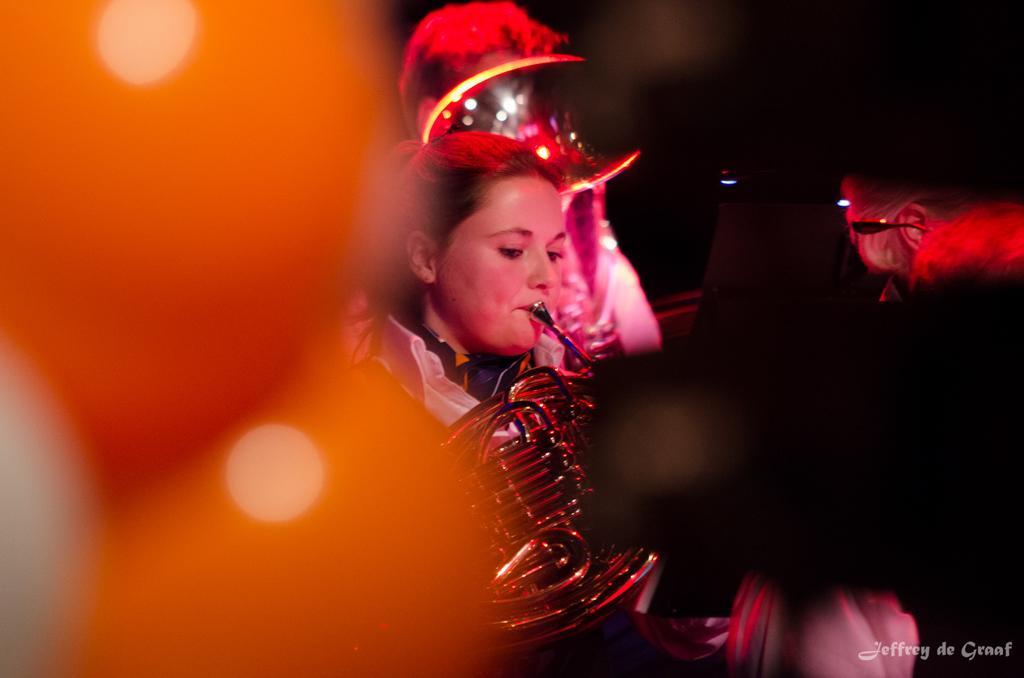Could you give a brief overview of what you see in this image? In this image there is a woman playing a musical instrument. Behind her there is a person. Right side there is a person. Background is blurry. 